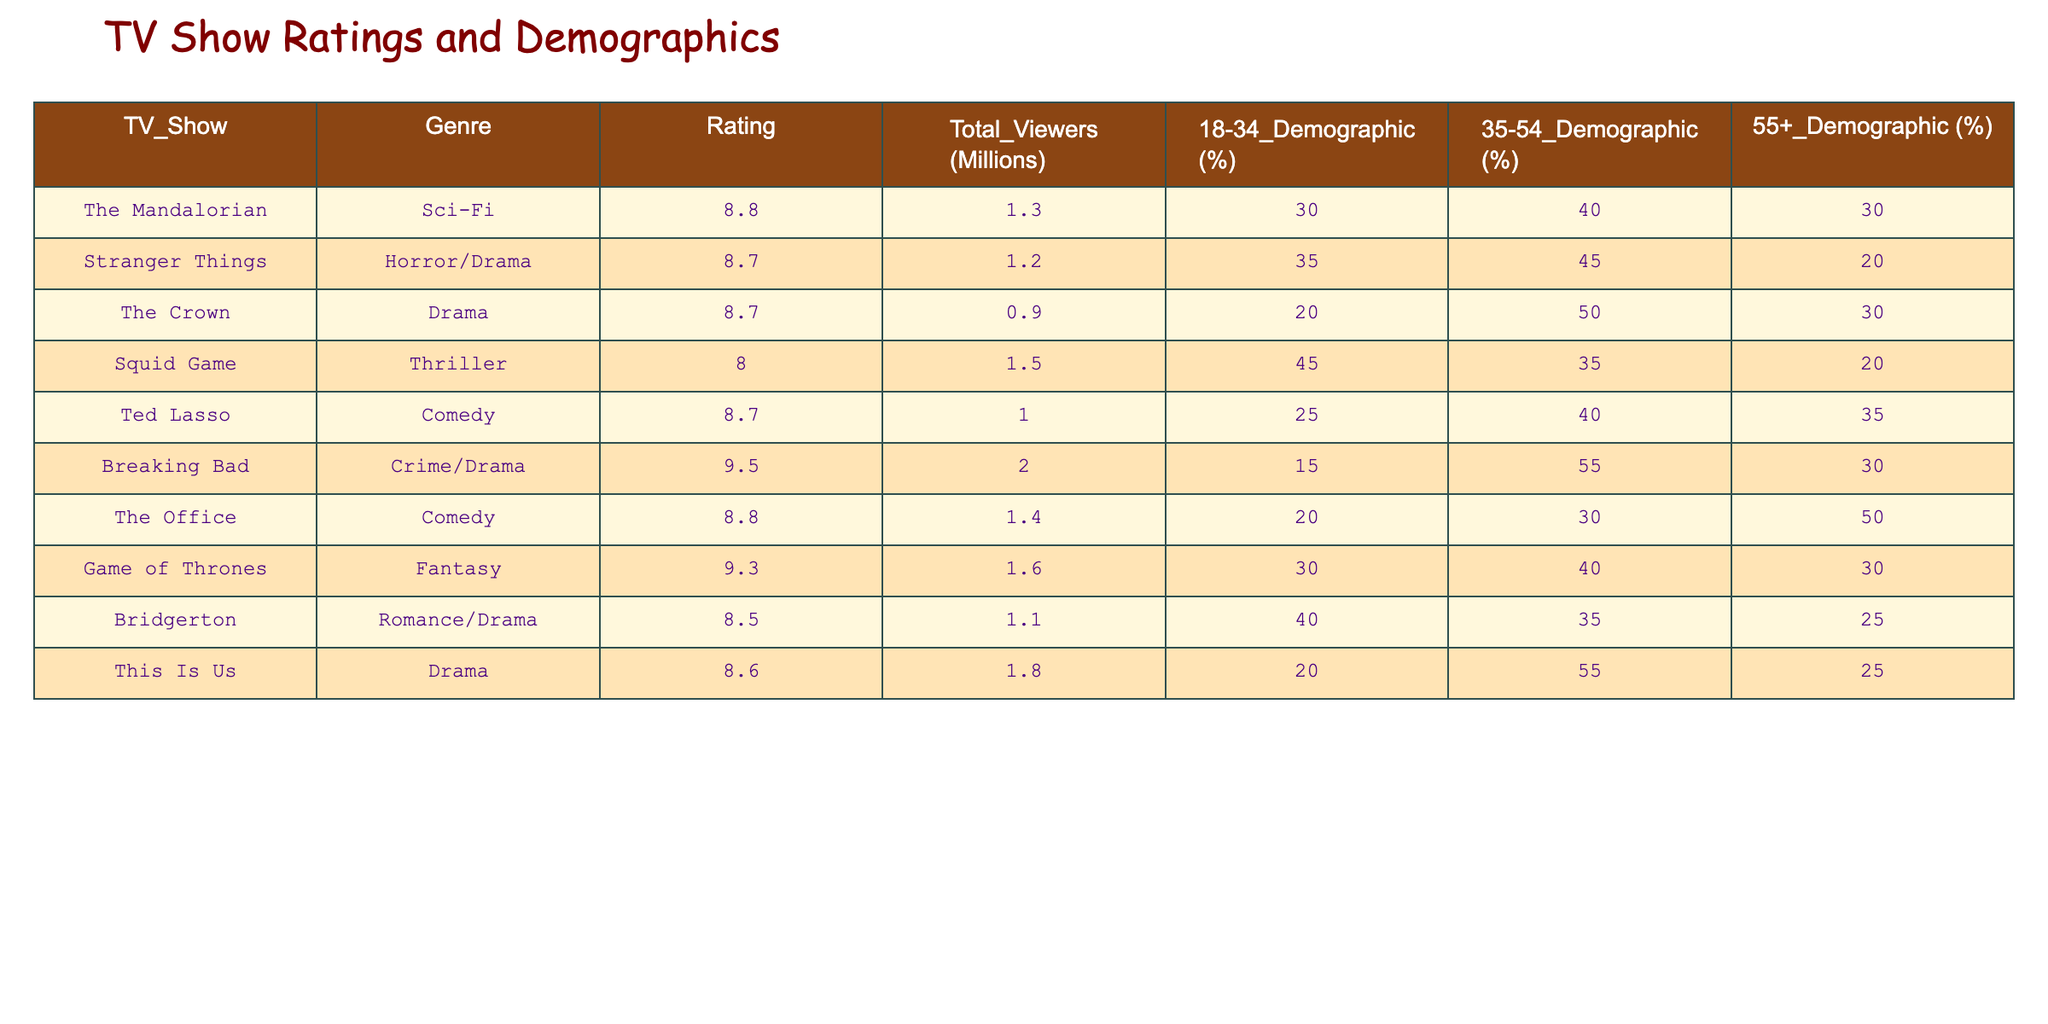What is the rating of "Breaking Bad"? The rating of "Breaking Bad" is listed directly in the table as 9.5.
Answer: 9.5 Which show has the highest total viewers? "Breaking Bad" has the highest total viewers with 2.0 million, as compared to other shows in the table.
Answer: 2.0 million What percentage of viewers aged 18-34 watched "Squid Game"? "Squid Game" has 45% of its viewers in the 18-34 demographic, as indicated in the table.
Answer: 45% Which genres are represented in the table? The genres provided in the table are Sci-Fi, Horror/Drama, Drama, Thriller, Comedy, Crime/Drama, Fantasy, and Romance/Drama, listed next to their respective shows.
Answer: Sci-Fi, Horror/Drama, Drama, Thriller, Comedy, Crime/Drama, Fantasy, Romance/Drama Is the average rating of shows in the table greater than 8.5? To find the average, we add the ratings: (8.8 + 8.7 + 8.7 + 8.0 + 8.7 + 9.5 + 8.8 + 9.3 + 8.5 + 8.6) = 87.6, and there are 10 shows. Thus, the average rating is 87.6/10 = 8.76, which is greater than 8.5.
Answer: Yes What is the difference between the percentage of 35-54 demographic viewers for "The Crown" and "This Is Us"? The percentage of 35-54 demographic viewers for "The Crown" is 50% and for "This Is Us" it is 55%. The difference is 55 - 50 = 5%.
Answer: 5% How many shows have a rating of 8.7 or higher? The shows with a rating of 8.7 or higher are "The Mandalorian", "Stranger Things", "The Crown", "Ted Lasso", "Breaking Bad", "The Office", "Game of Thrones", "This Is Us", which totals to 8 shows.
Answer: 8 For which show is the percentage of 55+ demographic viewers the lowest? In the table, "Squid Game" has 20% of its viewers in the 55+ demographic, which is lower than all the other shows.
Answer: Squid Game Does "The Office" have a higher percentage of viewers in the 18-34 demographic than "Ted Lasso"? "The Office" has 20% viewers in the 18-34 demographic and "Ted Lasso" has 25%. Since 20% is less than 25%, the statement is false.
Answer: No 